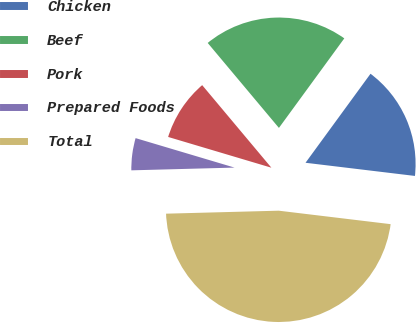<chart> <loc_0><loc_0><loc_500><loc_500><pie_chart><fcel>Chicken<fcel>Beef<fcel>Pork<fcel>Prepared Foods<fcel>Total<nl><fcel>16.87%<fcel>21.14%<fcel>9.29%<fcel>5.03%<fcel>47.67%<nl></chart> 